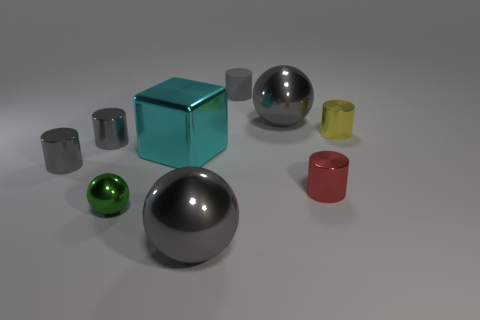Subtract all red blocks. How many gray cylinders are left? 3 Subtract all yellow cylinders. How many cylinders are left? 4 Subtract all yellow shiny cylinders. How many cylinders are left? 4 Subtract all blue cylinders. Subtract all yellow balls. How many cylinders are left? 5 Subtract all cylinders. How many objects are left? 4 Add 8 tiny brown metal cubes. How many tiny brown metal cubes exist? 8 Subtract 0 blue cubes. How many objects are left? 9 Subtract all gray shiny spheres. Subtract all big cyan objects. How many objects are left? 6 Add 5 shiny cylinders. How many shiny cylinders are left? 9 